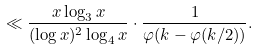Convert formula to latex. <formula><loc_0><loc_0><loc_500><loc_500>\ll \frac { x \log _ { 3 } x } { ( \log x ) ^ { 2 } \log _ { 4 } x } \cdot \frac { 1 } { \varphi ( k - \varphi ( k / 2 ) ) } .</formula> 